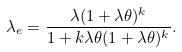<formula> <loc_0><loc_0><loc_500><loc_500>\lambda _ { e } = \frac { \lambda ( 1 + \lambda \theta ) ^ { k } } { 1 + k \lambda \theta ( 1 + \lambda \theta ) ^ { k } } .</formula> 